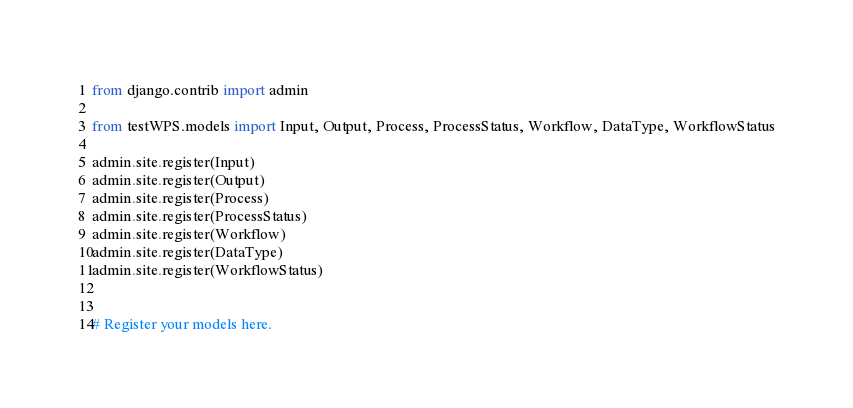Convert code to text. <code><loc_0><loc_0><loc_500><loc_500><_Python_>from django.contrib import admin

from testWPS.models import Input, Output, Process, ProcessStatus, Workflow, DataType, WorkflowStatus

admin.site.register(Input)
admin.site.register(Output)
admin.site.register(Process)
admin.site.register(ProcessStatus)
admin.site.register(Workflow)
admin.site.register(DataType)
admin.site.register(WorkflowStatus)


# Register your models here.
</code> 